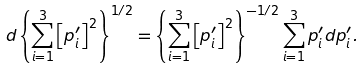Convert formula to latex. <formula><loc_0><loc_0><loc_500><loc_500>d \left \{ \sum _ { i = 1 } ^ { 3 } \left [ p ^ { \prime } _ { i } \right ] ^ { 2 } \right \} ^ { 1 / 2 } & = \left \{ \sum _ { i = 1 } ^ { 3 } \left [ p ^ { \prime } _ { i } \right ] ^ { 2 } \right \} ^ { - 1 / 2 } \sum _ { i = 1 } ^ { 3 } p ^ { \prime } _ { i } d p ^ { \prime } _ { i } .</formula> 